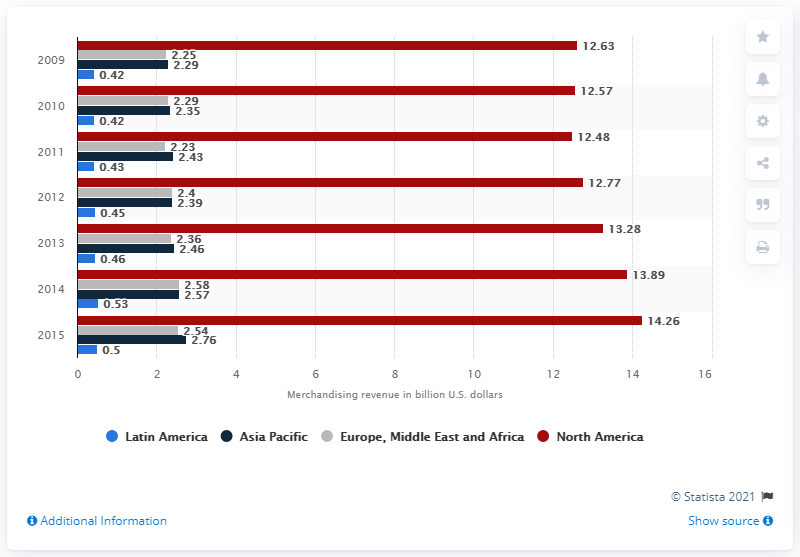Indicate a few pertinent items in this graphic. The projected revenue for the Asia Pacific region in 2011 was 2.43. In the year 2010, the total revenue generated worldwide from sports merchandising was generated by region. 